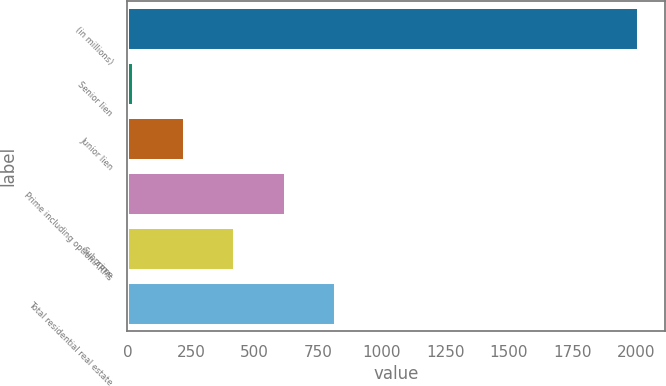Convert chart to OTSL. <chart><loc_0><loc_0><loc_500><loc_500><bar_chart><fcel>(in millions)<fcel>Senior lien<fcel>Junior lien<fcel>Prime including option ARMs<fcel>Subprime<fcel>Total residential real estate<nl><fcel>2012<fcel>27<fcel>225.5<fcel>622.5<fcel>424<fcel>821<nl></chart> 